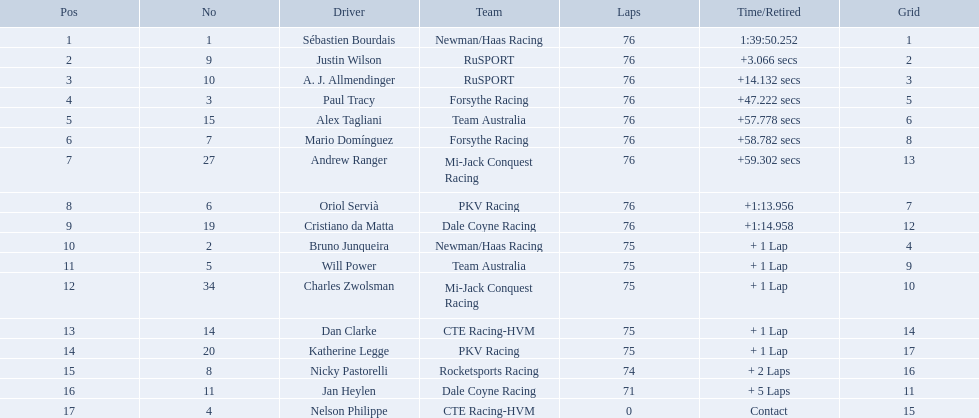What drivers took part in the 2006 tecate grand prix of monterrey? Sébastien Bourdais, Justin Wilson, A. J. Allmendinger, Paul Tracy, Alex Tagliani, Mario Domínguez, Andrew Ranger, Oriol Servià, Cristiano da Matta, Bruno Junqueira, Will Power, Charles Zwolsman, Dan Clarke, Katherine Legge, Nicky Pastorelli, Jan Heylen, Nelson Philippe. Which of those drivers scored the same amount of points as another driver? Charles Zwolsman, Dan Clarke. Who had the same amount of points as charles zwolsman? Dan Clarke. Is there a driver named charles zwolsman? Charles Zwolsman. How many points did he acquire? 9. Were there any other entries that got the same number of points? 9. Who did that entry belong to? Dan Clarke. 